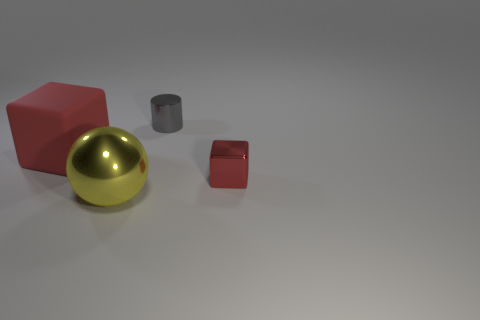What shape is the metallic object that is both behind the yellow thing and to the left of the small metal block?
Give a very brief answer. Cylinder. There is a big yellow metallic object in front of the shiny block; what number of objects are left of it?
Your answer should be compact. 1. Is there any other thing that is the same material as the big red thing?
Keep it short and to the point. No. How many objects are either objects to the right of the big red rubber block or large shiny balls?
Make the answer very short. 3. What is the size of the red cube left of the gray metallic cylinder?
Make the answer very short. Large. What is the small gray cylinder made of?
Provide a short and direct response. Metal. There is a red thing that is to the right of the metal thing on the left side of the tiny gray object; what is its shape?
Give a very brief answer. Cube. What number of other objects are there of the same shape as the gray thing?
Your answer should be very brief. 0. There is a large yellow thing; are there any red cubes right of it?
Provide a succinct answer. Yes. What is the color of the cylinder?
Your answer should be very brief. Gray. 